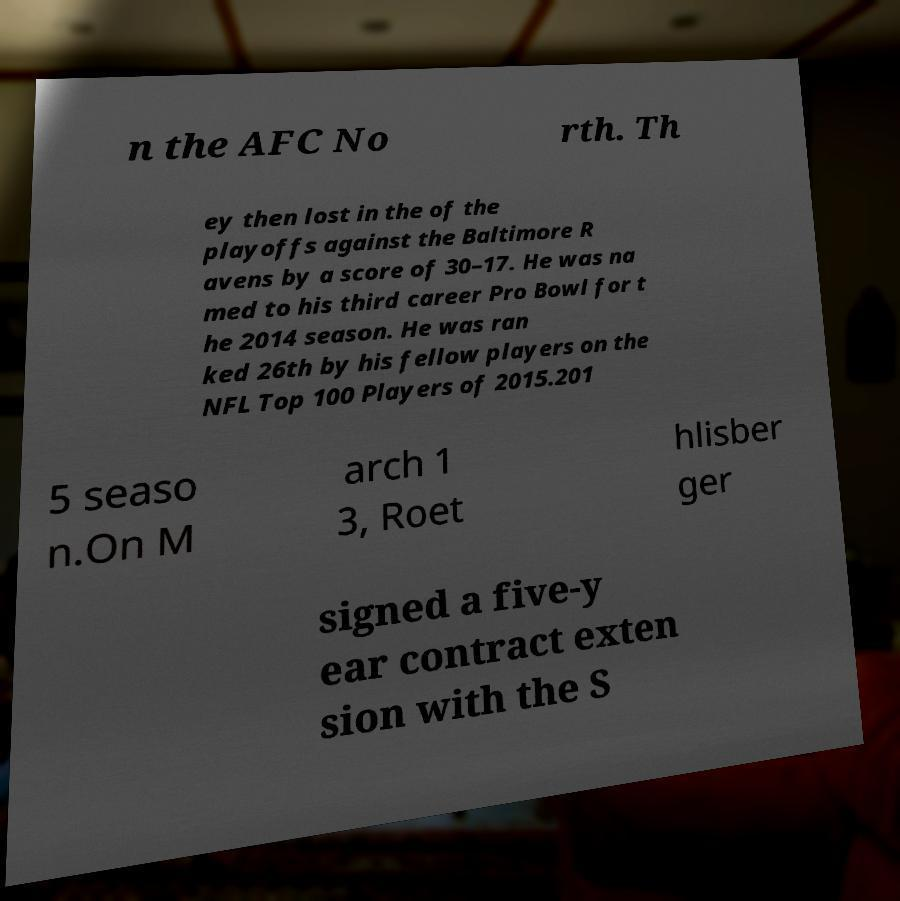I need the written content from this picture converted into text. Can you do that? n the AFC No rth. Th ey then lost in the of the playoffs against the Baltimore R avens by a score of 30–17. He was na med to his third career Pro Bowl for t he 2014 season. He was ran ked 26th by his fellow players on the NFL Top 100 Players of 2015.201 5 seaso n.On M arch 1 3, Roet hlisber ger signed a five-y ear contract exten sion with the S 